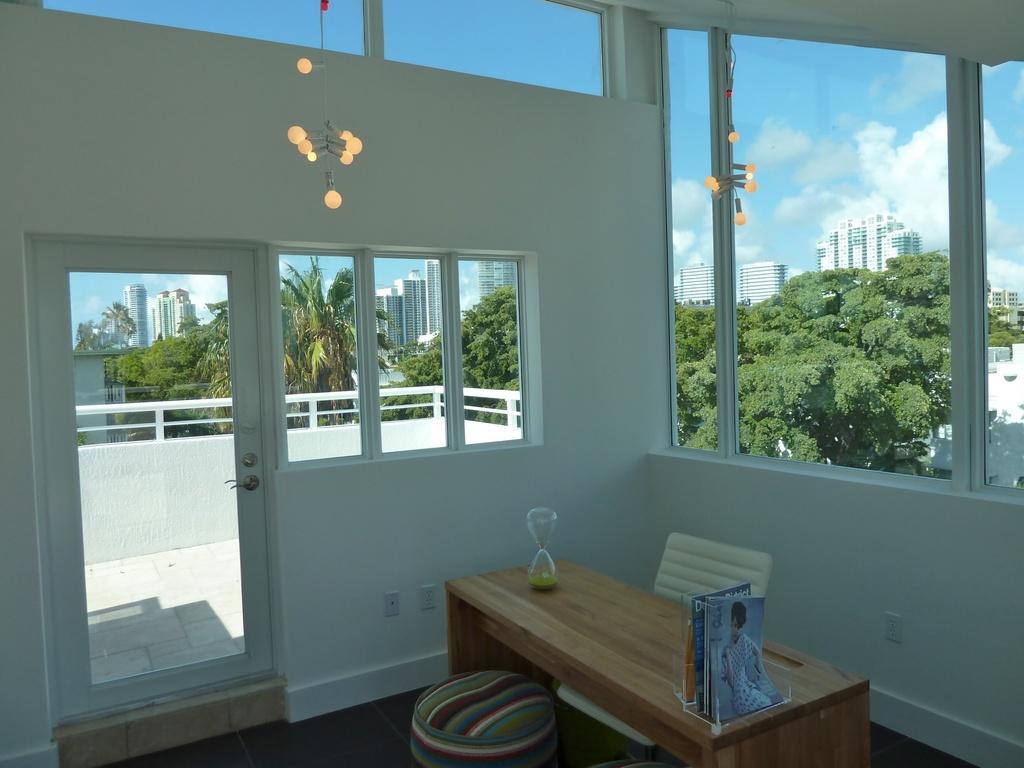Describe this image in one or two sentences. This picture is an inside view of a room. In this picture we can see a table, chair, books, floor, wall, door, handle, lights, windows, glass. Through glass we can see the trees, buildings and clouds are present in the sky. At the bottom of the image we can see the floor. 